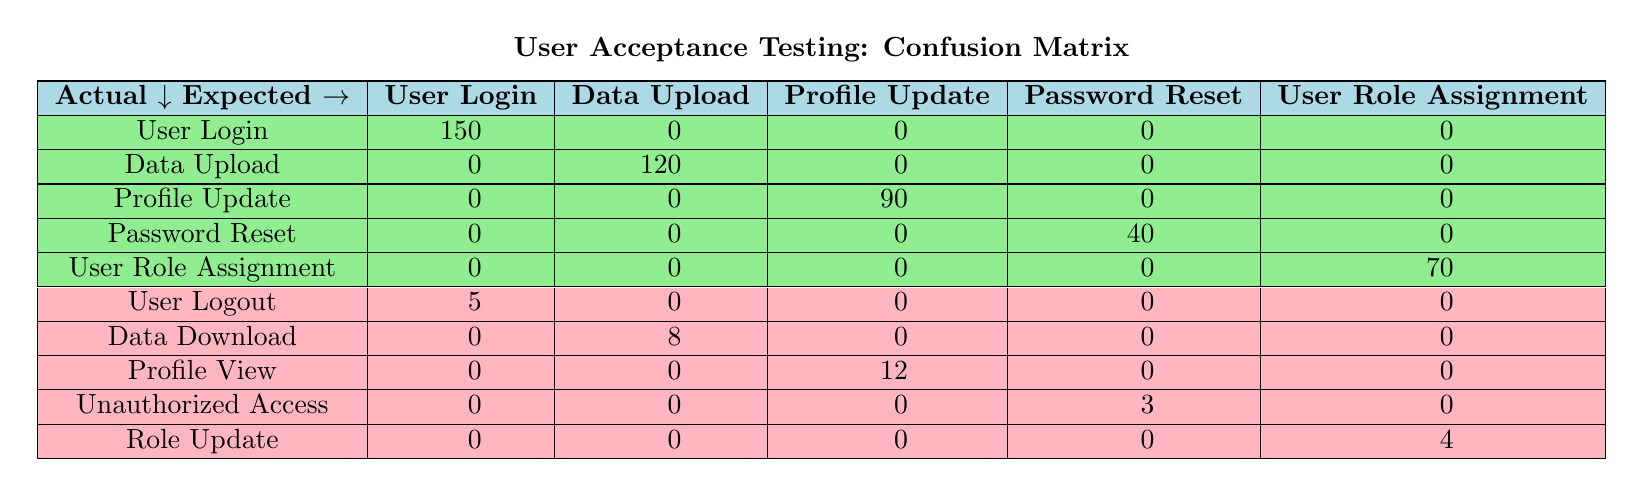What is the count of actual outcomes for "User Login"? According to the table, the count for the actual outcome "User Login" under the expected outcome "User Login" is 150.
Answer: 150 How many expected functionalities have actual outcomes that match them? The table shows that "User Login," "Data Upload," "Profile Update," "Password Reset," and "User Role Assignment" all have matching actual outcomes, which gives us a total of 5 expected functionalities with matches.
Answer: 5 What is the total count of mismatches across all functionalities? The mismatches are the counts for "User Logout," "Data Download," "Profile View," "Unauthorized Access," and "Role Update," which total 5 + 8 + 12 + 3 + 4 = 32. This means there are 32 mismatches in total across all functionalities.
Answer: 32 Are there any functionalities with no mismatched outcomes? Yes, the functionalities "User Login," "Data Upload," "Profile Update," "Password Reset," and "User Role Assignment" show no mismatches as they only indicate expected outcomes.
Answer: Yes What is the difference in count between the expected outcome "Password Reset" and its actual outcome "Unauthorized Access"? The count for the expected outcome "Password Reset" that matched is 40, while the mismatched outcome "Unauthorized Access" has a count of 3. Thus, the difference is 40 - 3 = 37.
Answer: 37 What percentage of total tests resulted in expected outcomes? To calculate this, we add up all the counts: (150 + 120 + 90 + 40 + 70) = 470 for expected matches and (5 + 8 + 12 + 3 + 4) = 32 for mismatches, so total tests = 470 + 32 = 502. The percentage of expected outcomes = (470 / 502) * 100 ≈ 93.7%.
Answer: Approximately 93.7% Which expected functionality had the highest number of mismatches? By reviewing the mismatches, "Profile View" had 12, "Data Download" had 8, and "User Logout" had 5. Therefore, "Profile View" had the highest number of mismatches at 12.
Answer: Profile View If we consider only the actual outcomes, how many unique functionalities were tested? The table shows actual outcomes like "User Login," "User Logout," "Data Upload," "Data Download," "Profile Update," "Profile View," "Password Reset," "Unauthorized Access," "User Role Assignment," and "Role Update." Counting these gives 10 unique functionalities tested.
Answer: 10 